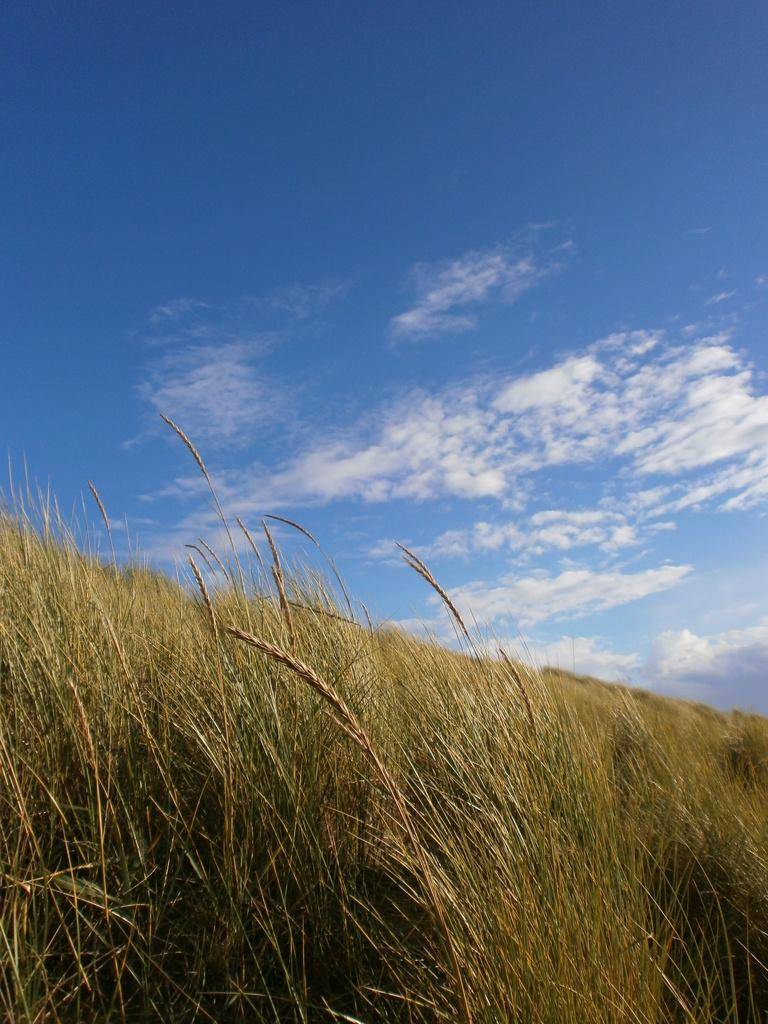What type of terrain is visible in the image? There is a lawn in the image. What material can be seen in the image? There is straw in the image. What is visible in the background of the image? The sky is visible in the background of the image. What can be observed in the sky? There are clouds in the sky. What type of skirt is being worn by the tent in the image? There is no tent or skirt present in the image. 